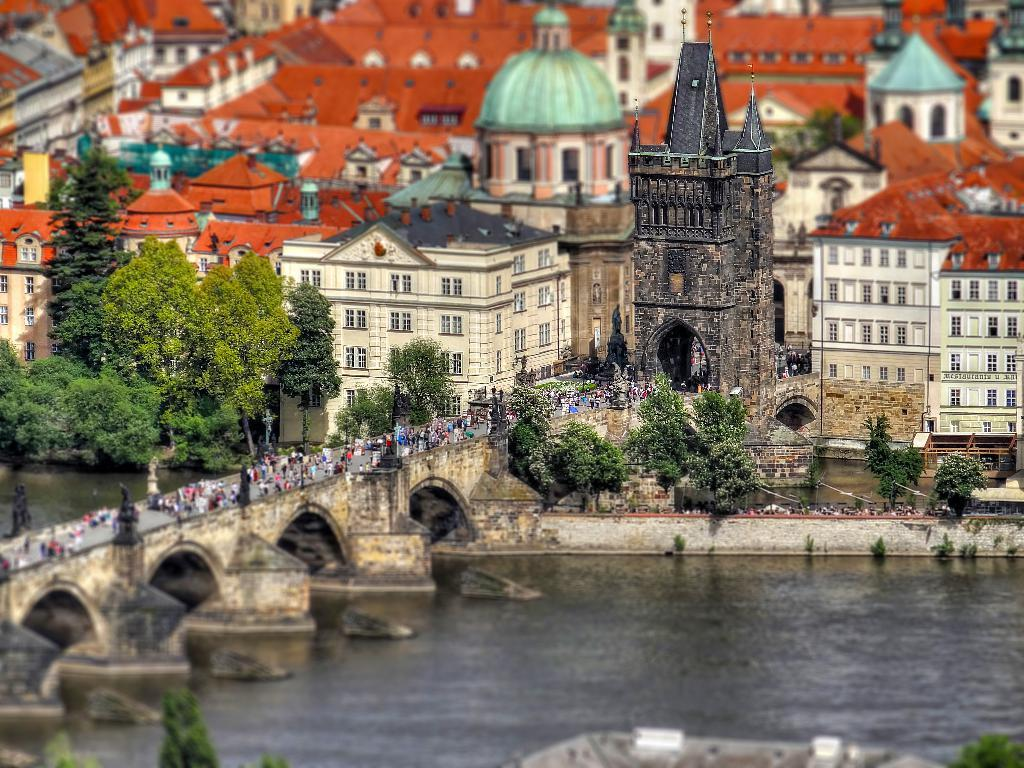What type of structures can be seen in the image? There are many buildings and a tower in the image. What natural elements are present in the image? There are trees and a river in the image. What architectural feature is present to cross the river? There is a bridge in the image to cross the river. How many people can be seen in the image? There are many people in the image. Can you tell me what type of guitar is being played by the person on the bridge? There is no guitar or person playing a guitar present in the image. What adjustment can be made to the level of the river in the image? There is no mention of adjusting the level of the river in the image, nor is there any indication that it is possible to do so. 